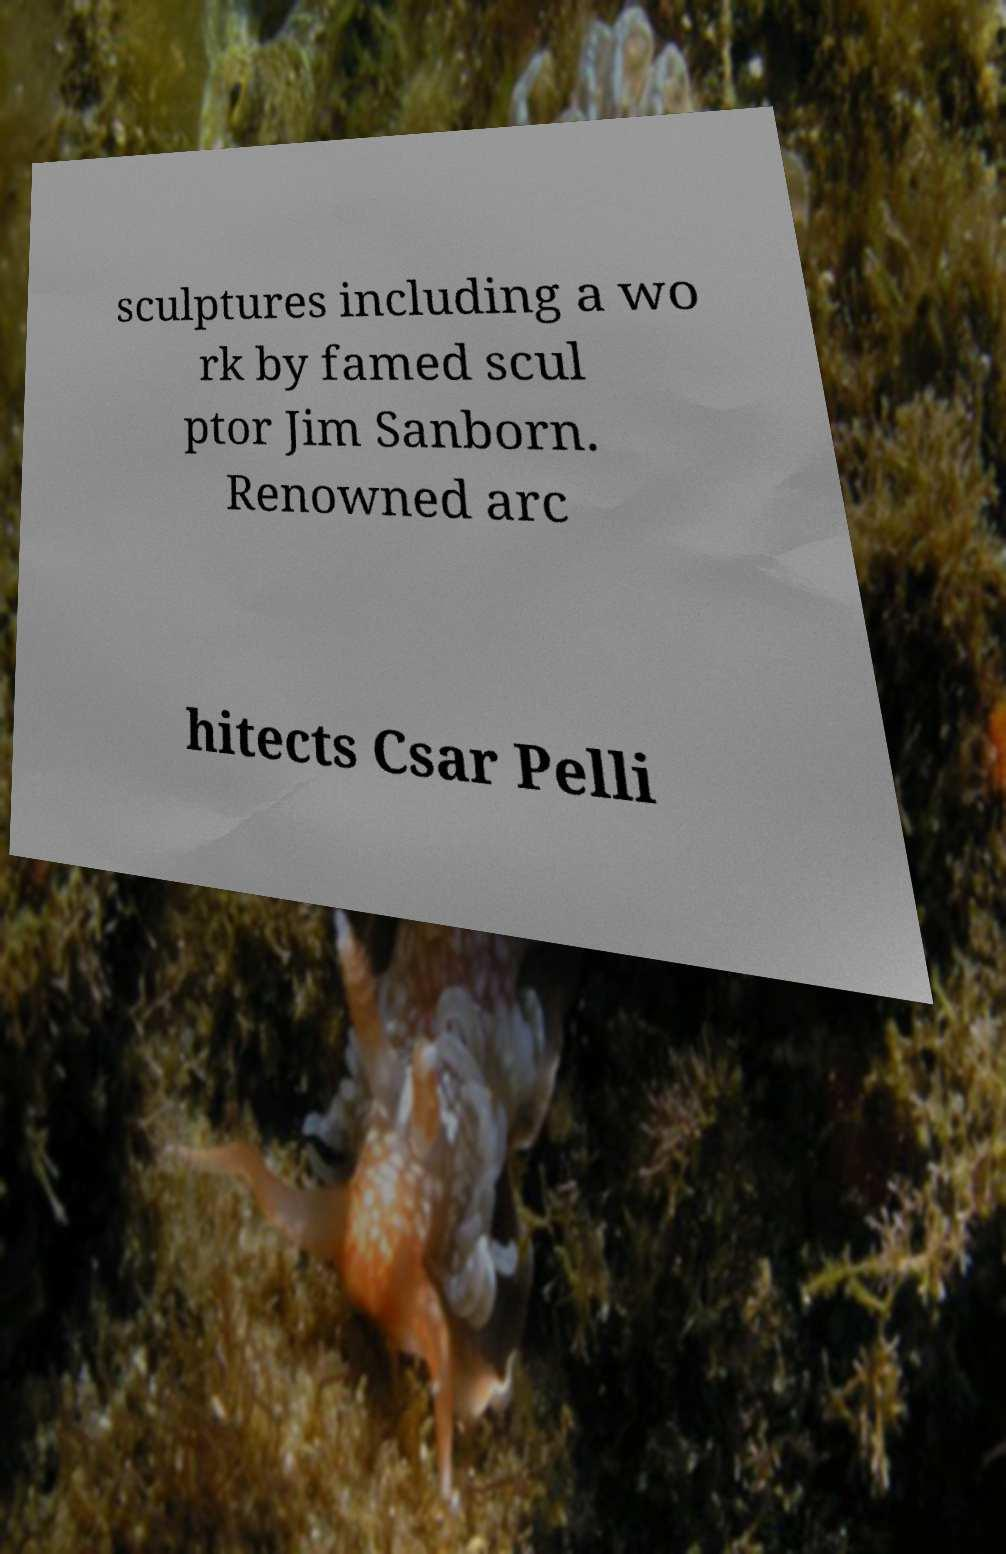There's text embedded in this image that I need extracted. Can you transcribe it verbatim? sculptures including a wo rk by famed scul ptor Jim Sanborn. Renowned arc hitects Csar Pelli 